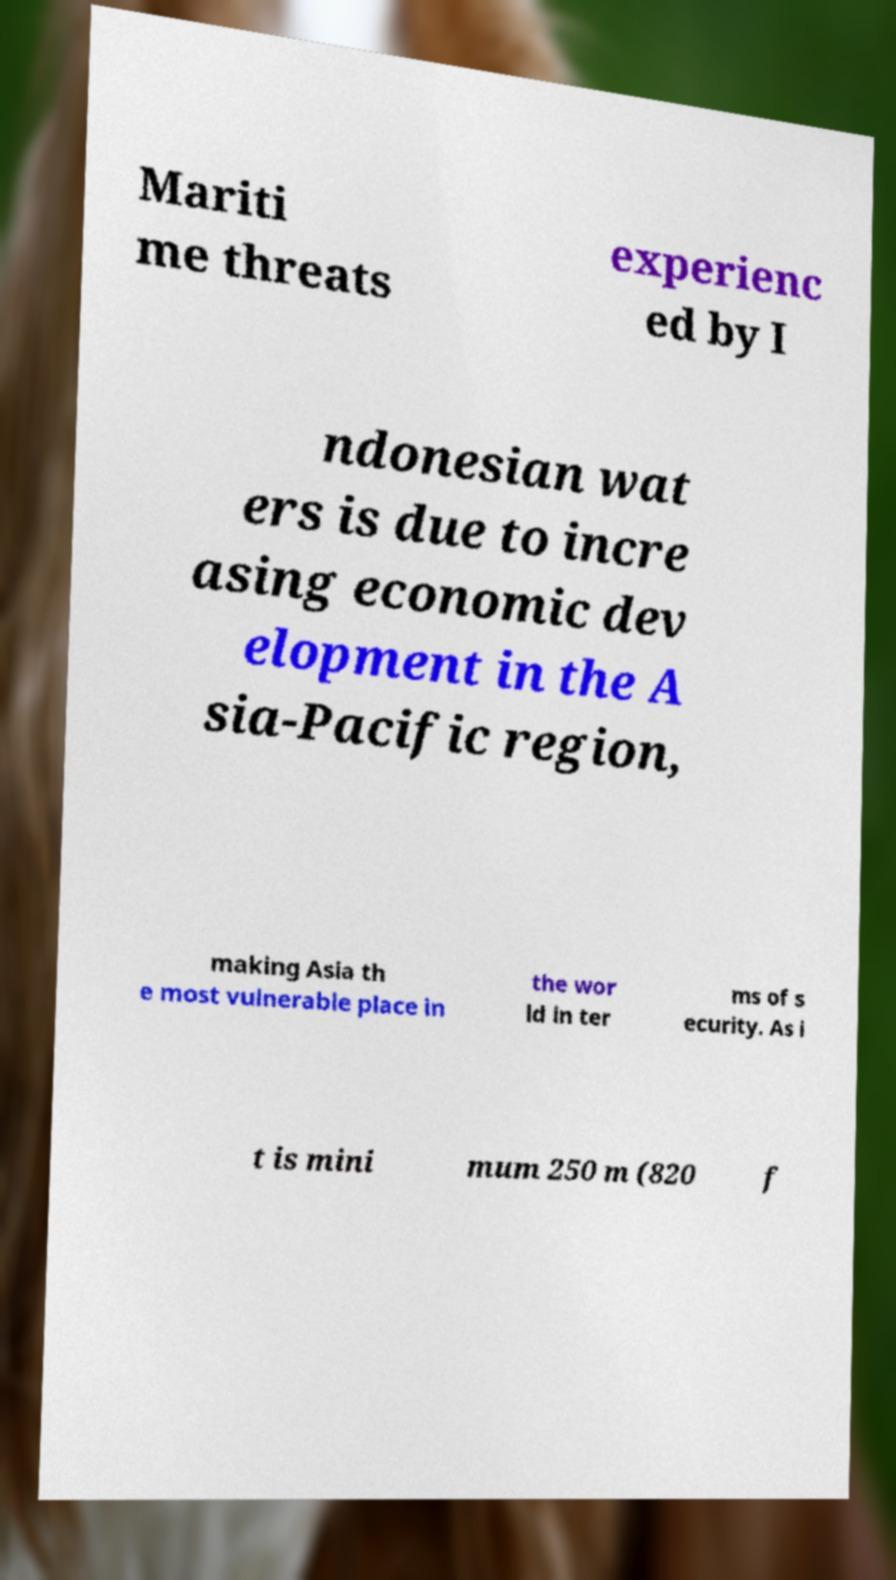Could you extract and type out the text from this image? Mariti me threats experienc ed by I ndonesian wat ers is due to incre asing economic dev elopment in the A sia-Pacific region, making Asia th e most vulnerable place in the wor ld in ter ms of s ecurity. As i t is mini mum 250 m (820 f 